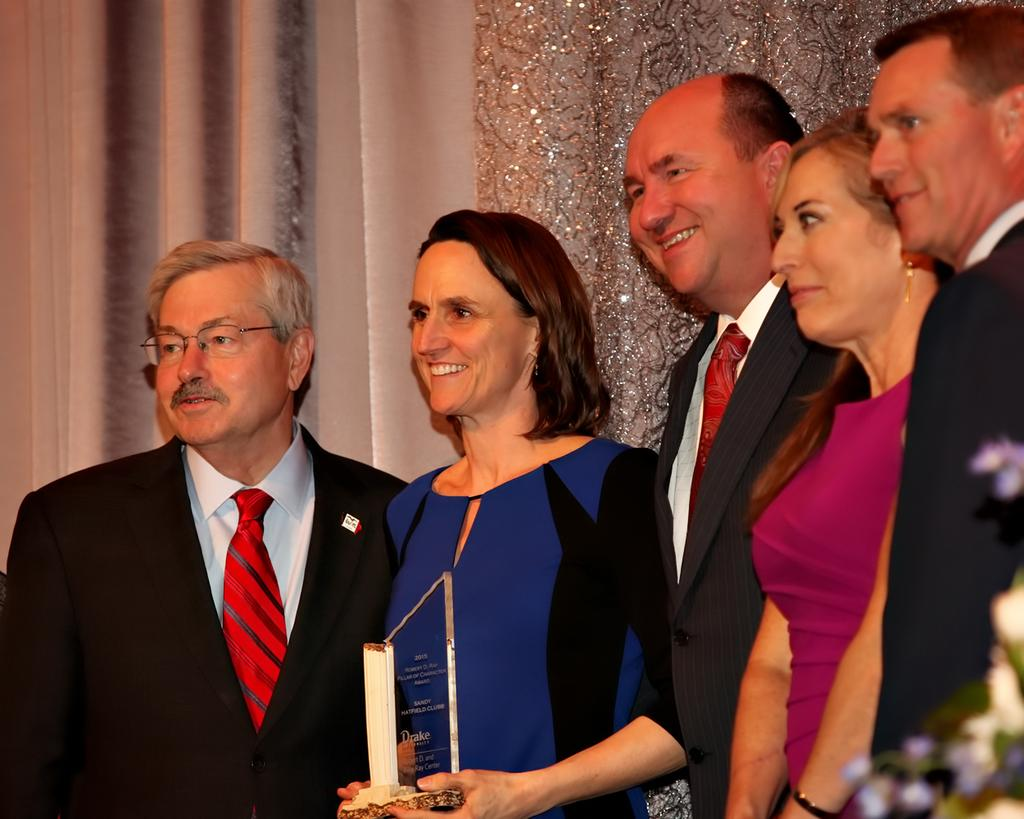Who is present in the image? There are people in the image. What are the people doing in the image? The people are standing and smiling. What can be seen in the background of the image? There are curtains visible in the image. What type of kitty is sitting on the person's shoulder in the image? There is no kitty present in the image; only people are visible. 